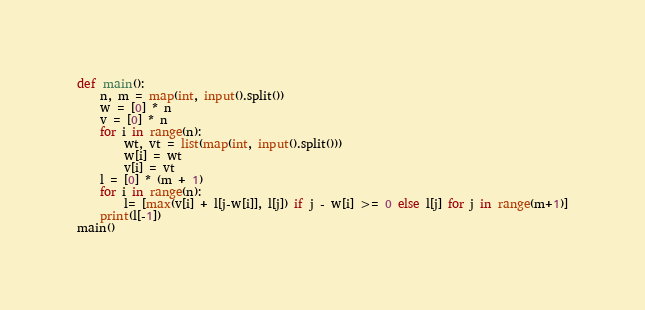<code> <loc_0><loc_0><loc_500><loc_500><_Python_>def main():
    n, m = map(int, input().split())
    w = [0] * n
    v = [0] * n
    for i in range(n):
        wt, vt = list(map(int, input().split()))
        w[i] = wt
        v[i] = vt
    l = [0] * (m + 1)
    for i in range(n):
        l= [max(v[i] + l[j-w[i]], l[j]) if j - w[i] >= 0 else l[j] for j in range(m+1)]
    print(l[-1])
main()
</code> 